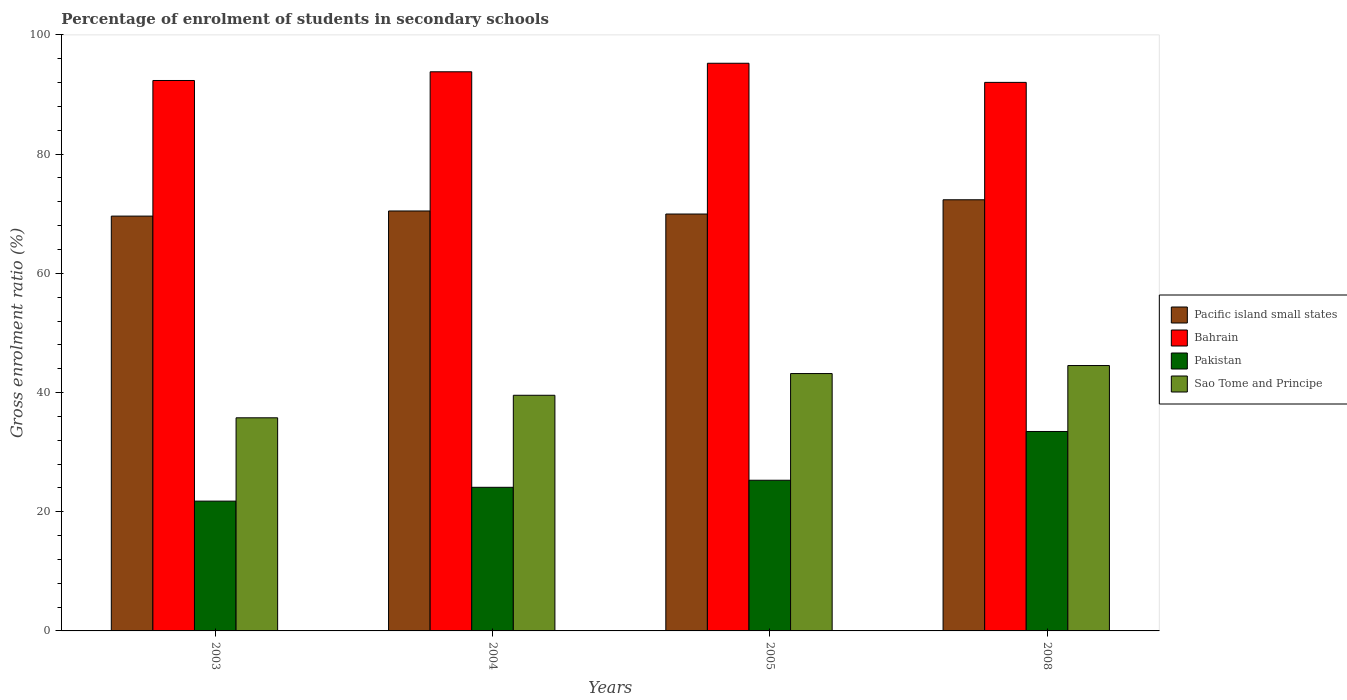How many groups of bars are there?
Your answer should be very brief. 4. Are the number of bars on each tick of the X-axis equal?
Your answer should be compact. Yes. In how many cases, is the number of bars for a given year not equal to the number of legend labels?
Your answer should be very brief. 0. What is the percentage of students enrolled in secondary schools in Sao Tome and Principe in 2005?
Provide a succinct answer. 43.18. Across all years, what is the maximum percentage of students enrolled in secondary schools in Pakistan?
Provide a short and direct response. 33.46. Across all years, what is the minimum percentage of students enrolled in secondary schools in Pacific island small states?
Your response must be concise. 69.6. What is the total percentage of students enrolled in secondary schools in Pakistan in the graph?
Give a very brief answer. 104.62. What is the difference between the percentage of students enrolled in secondary schools in Bahrain in 2003 and that in 2008?
Keep it short and to the point. 0.32. What is the difference between the percentage of students enrolled in secondary schools in Pakistan in 2008 and the percentage of students enrolled in secondary schools in Pacific island small states in 2003?
Provide a short and direct response. -36.14. What is the average percentage of students enrolled in secondary schools in Bahrain per year?
Your response must be concise. 93.36. In the year 2003, what is the difference between the percentage of students enrolled in secondary schools in Pacific island small states and percentage of students enrolled in secondary schools in Pakistan?
Your answer should be very brief. 47.82. What is the ratio of the percentage of students enrolled in secondary schools in Pacific island small states in 2004 to that in 2008?
Your answer should be compact. 0.97. Is the percentage of students enrolled in secondary schools in Sao Tome and Principe in 2003 less than that in 2005?
Give a very brief answer. Yes. What is the difference between the highest and the second highest percentage of students enrolled in secondary schools in Pakistan?
Your answer should be very brief. 8.18. What is the difference between the highest and the lowest percentage of students enrolled in secondary schools in Sao Tome and Principe?
Offer a terse response. 8.77. In how many years, is the percentage of students enrolled in secondary schools in Pakistan greater than the average percentage of students enrolled in secondary schools in Pakistan taken over all years?
Provide a succinct answer. 1. What does the 2nd bar from the left in 2003 represents?
Your answer should be very brief. Bahrain. Are all the bars in the graph horizontal?
Give a very brief answer. No. What is the difference between two consecutive major ticks on the Y-axis?
Provide a succinct answer. 20. Are the values on the major ticks of Y-axis written in scientific E-notation?
Keep it short and to the point. No. Does the graph contain grids?
Ensure brevity in your answer.  No. How many legend labels are there?
Offer a terse response. 4. How are the legend labels stacked?
Your answer should be compact. Vertical. What is the title of the graph?
Provide a short and direct response. Percentage of enrolment of students in secondary schools. Does "Bermuda" appear as one of the legend labels in the graph?
Make the answer very short. No. What is the Gross enrolment ratio (%) in Pacific island small states in 2003?
Make the answer very short. 69.6. What is the Gross enrolment ratio (%) in Bahrain in 2003?
Offer a very short reply. 92.35. What is the Gross enrolment ratio (%) of Pakistan in 2003?
Offer a terse response. 21.78. What is the Gross enrolment ratio (%) of Sao Tome and Principe in 2003?
Offer a very short reply. 35.76. What is the Gross enrolment ratio (%) in Pacific island small states in 2004?
Provide a short and direct response. 70.46. What is the Gross enrolment ratio (%) of Bahrain in 2004?
Your response must be concise. 93.81. What is the Gross enrolment ratio (%) of Pakistan in 2004?
Provide a short and direct response. 24.1. What is the Gross enrolment ratio (%) of Sao Tome and Principe in 2004?
Your answer should be compact. 39.54. What is the Gross enrolment ratio (%) of Pacific island small states in 2005?
Offer a terse response. 69.95. What is the Gross enrolment ratio (%) in Bahrain in 2005?
Make the answer very short. 95.25. What is the Gross enrolment ratio (%) of Pakistan in 2005?
Your response must be concise. 25.28. What is the Gross enrolment ratio (%) of Sao Tome and Principe in 2005?
Make the answer very short. 43.18. What is the Gross enrolment ratio (%) of Pacific island small states in 2008?
Your response must be concise. 72.34. What is the Gross enrolment ratio (%) in Bahrain in 2008?
Give a very brief answer. 92.04. What is the Gross enrolment ratio (%) in Pakistan in 2008?
Offer a very short reply. 33.46. What is the Gross enrolment ratio (%) of Sao Tome and Principe in 2008?
Give a very brief answer. 44.53. Across all years, what is the maximum Gross enrolment ratio (%) in Pacific island small states?
Give a very brief answer. 72.34. Across all years, what is the maximum Gross enrolment ratio (%) in Bahrain?
Your answer should be compact. 95.25. Across all years, what is the maximum Gross enrolment ratio (%) of Pakistan?
Your answer should be very brief. 33.46. Across all years, what is the maximum Gross enrolment ratio (%) in Sao Tome and Principe?
Your response must be concise. 44.53. Across all years, what is the minimum Gross enrolment ratio (%) in Pacific island small states?
Offer a terse response. 69.6. Across all years, what is the minimum Gross enrolment ratio (%) in Bahrain?
Your response must be concise. 92.04. Across all years, what is the minimum Gross enrolment ratio (%) of Pakistan?
Your answer should be compact. 21.78. Across all years, what is the minimum Gross enrolment ratio (%) in Sao Tome and Principe?
Make the answer very short. 35.76. What is the total Gross enrolment ratio (%) in Pacific island small states in the graph?
Provide a succinct answer. 282.35. What is the total Gross enrolment ratio (%) in Bahrain in the graph?
Offer a very short reply. 373.45. What is the total Gross enrolment ratio (%) of Pakistan in the graph?
Ensure brevity in your answer.  104.62. What is the total Gross enrolment ratio (%) in Sao Tome and Principe in the graph?
Ensure brevity in your answer.  163.01. What is the difference between the Gross enrolment ratio (%) of Pacific island small states in 2003 and that in 2004?
Your answer should be very brief. -0.86. What is the difference between the Gross enrolment ratio (%) in Bahrain in 2003 and that in 2004?
Make the answer very short. -1.46. What is the difference between the Gross enrolment ratio (%) in Pakistan in 2003 and that in 2004?
Provide a succinct answer. -2.32. What is the difference between the Gross enrolment ratio (%) in Sao Tome and Principe in 2003 and that in 2004?
Offer a terse response. -3.78. What is the difference between the Gross enrolment ratio (%) of Pacific island small states in 2003 and that in 2005?
Your answer should be compact. -0.35. What is the difference between the Gross enrolment ratio (%) in Bahrain in 2003 and that in 2005?
Make the answer very short. -2.89. What is the difference between the Gross enrolment ratio (%) in Pakistan in 2003 and that in 2005?
Your answer should be compact. -3.5. What is the difference between the Gross enrolment ratio (%) in Sao Tome and Principe in 2003 and that in 2005?
Offer a very short reply. -7.42. What is the difference between the Gross enrolment ratio (%) in Pacific island small states in 2003 and that in 2008?
Offer a very short reply. -2.74. What is the difference between the Gross enrolment ratio (%) in Bahrain in 2003 and that in 2008?
Give a very brief answer. 0.32. What is the difference between the Gross enrolment ratio (%) of Pakistan in 2003 and that in 2008?
Provide a short and direct response. -11.69. What is the difference between the Gross enrolment ratio (%) of Sao Tome and Principe in 2003 and that in 2008?
Your response must be concise. -8.77. What is the difference between the Gross enrolment ratio (%) in Pacific island small states in 2004 and that in 2005?
Offer a very short reply. 0.51. What is the difference between the Gross enrolment ratio (%) of Bahrain in 2004 and that in 2005?
Provide a succinct answer. -1.43. What is the difference between the Gross enrolment ratio (%) in Pakistan in 2004 and that in 2005?
Make the answer very short. -1.18. What is the difference between the Gross enrolment ratio (%) in Sao Tome and Principe in 2004 and that in 2005?
Give a very brief answer. -3.64. What is the difference between the Gross enrolment ratio (%) of Pacific island small states in 2004 and that in 2008?
Offer a very short reply. -1.88. What is the difference between the Gross enrolment ratio (%) of Bahrain in 2004 and that in 2008?
Make the answer very short. 1.78. What is the difference between the Gross enrolment ratio (%) of Pakistan in 2004 and that in 2008?
Keep it short and to the point. -9.37. What is the difference between the Gross enrolment ratio (%) of Sao Tome and Principe in 2004 and that in 2008?
Offer a very short reply. -4.99. What is the difference between the Gross enrolment ratio (%) of Pacific island small states in 2005 and that in 2008?
Offer a terse response. -2.39. What is the difference between the Gross enrolment ratio (%) of Bahrain in 2005 and that in 2008?
Your response must be concise. 3.21. What is the difference between the Gross enrolment ratio (%) of Pakistan in 2005 and that in 2008?
Provide a short and direct response. -8.18. What is the difference between the Gross enrolment ratio (%) in Sao Tome and Principe in 2005 and that in 2008?
Ensure brevity in your answer.  -1.34. What is the difference between the Gross enrolment ratio (%) of Pacific island small states in 2003 and the Gross enrolment ratio (%) of Bahrain in 2004?
Your response must be concise. -24.21. What is the difference between the Gross enrolment ratio (%) of Pacific island small states in 2003 and the Gross enrolment ratio (%) of Pakistan in 2004?
Provide a short and direct response. 45.5. What is the difference between the Gross enrolment ratio (%) of Pacific island small states in 2003 and the Gross enrolment ratio (%) of Sao Tome and Principe in 2004?
Your answer should be compact. 30.06. What is the difference between the Gross enrolment ratio (%) in Bahrain in 2003 and the Gross enrolment ratio (%) in Pakistan in 2004?
Provide a short and direct response. 68.26. What is the difference between the Gross enrolment ratio (%) of Bahrain in 2003 and the Gross enrolment ratio (%) of Sao Tome and Principe in 2004?
Make the answer very short. 52.82. What is the difference between the Gross enrolment ratio (%) in Pakistan in 2003 and the Gross enrolment ratio (%) in Sao Tome and Principe in 2004?
Give a very brief answer. -17.76. What is the difference between the Gross enrolment ratio (%) of Pacific island small states in 2003 and the Gross enrolment ratio (%) of Bahrain in 2005?
Keep it short and to the point. -25.65. What is the difference between the Gross enrolment ratio (%) in Pacific island small states in 2003 and the Gross enrolment ratio (%) in Pakistan in 2005?
Your answer should be very brief. 44.32. What is the difference between the Gross enrolment ratio (%) of Pacific island small states in 2003 and the Gross enrolment ratio (%) of Sao Tome and Principe in 2005?
Make the answer very short. 26.42. What is the difference between the Gross enrolment ratio (%) of Bahrain in 2003 and the Gross enrolment ratio (%) of Pakistan in 2005?
Provide a short and direct response. 67.07. What is the difference between the Gross enrolment ratio (%) of Bahrain in 2003 and the Gross enrolment ratio (%) of Sao Tome and Principe in 2005?
Keep it short and to the point. 49.17. What is the difference between the Gross enrolment ratio (%) of Pakistan in 2003 and the Gross enrolment ratio (%) of Sao Tome and Principe in 2005?
Your response must be concise. -21.4. What is the difference between the Gross enrolment ratio (%) of Pacific island small states in 2003 and the Gross enrolment ratio (%) of Bahrain in 2008?
Offer a very short reply. -22.44. What is the difference between the Gross enrolment ratio (%) of Pacific island small states in 2003 and the Gross enrolment ratio (%) of Pakistan in 2008?
Your answer should be very brief. 36.14. What is the difference between the Gross enrolment ratio (%) in Pacific island small states in 2003 and the Gross enrolment ratio (%) in Sao Tome and Principe in 2008?
Your answer should be compact. 25.07. What is the difference between the Gross enrolment ratio (%) in Bahrain in 2003 and the Gross enrolment ratio (%) in Pakistan in 2008?
Ensure brevity in your answer.  58.89. What is the difference between the Gross enrolment ratio (%) of Bahrain in 2003 and the Gross enrolment ratio (%) of Sao Tome and Principe in 2008?
Ensure brevity in your answer.  47.83. What is the difference between the Gross enrolment ratio (%) of Pakistan in 2003 and the Gross enrolment ratio (%) of Sao Tome and Principe in 2008?
Make the answer very short. -22.75. What is the difference between the Gross enrolment ratio (%) of Pacific island small states in 2004 and the Gross enrolment ratio (%) of Bahrain in 2005?
Offer a terse response. -24.79. What is the difference between the Gross enrolment ratio (%) of Pacific island small states in 2004 and the Gross enrolment ratio (%) of Pakistan in 2005?
Give a very brief answer. 45.18. What is the difference between the Gross enrolment ratio (%) in Pacific island small states in 2004 and the Gross enrolment ratio (%) in Sao Tome and Principe in 2005?
Give a very brief answer. 27.28. What is the difference between the Gross enrolment ratio (%) of Bahrain in 2004 and the Gross enrolment ratio (%) of Pakistan in 2005?
Make the answer very short. 68.53. What is the difference between the Gross enrolment ratio (%) of Bahrain in 2004 and the Gross enrolment ratio (%) of Sao Tome and Principe in 2005?
Give a very brief answer. 50.63. What is the difference between the Gross enrolment ratio (%) in Pakistan in 2004 and the Gross enrolment ratio (%) in Sao Tome and Principe in 2005?
Offer a very short reply. -19.08. What is the difference between the Gross enrolment ratio (%) of Pacific island small states in 2004 and the Gross enrolment ratio (%) of Bahrain in 2008?
Your response must be concise. -21.58. What is the difference between the Gross enrolment ratio (%) in Pacific island small states in 2004 and the Gross enrolment ratio (%) in Pakistan in 2008?
Keep it short and to the point. 37. What is the difference between the Gross enrolment ratio (%) of Pacific island small states in 2004 and the Gross enrolment ratio (%) of Sao Tome and Principe in 2008?
Provide a short and direct response. 25.93. What is the difference between the Gross enrolment ratio (%) in Bahrain in 2004 and the Gross enrolment ratio (%) in Pakistan in 2008?
Offer a terse response. 60.35. What is the difference between the Gross enrolment ratio (%) of Bahrain in 2004 and the Gross enrolment ratio (%) of Sao Tome and Principe in 2008?
Your answer should be compact. 49.29. What is the difference between the Gross enrolment ratio (%) of Pakistan in 2004 and the Gross enrolment ratio (%) of Sao Tome and Principe in 2008?
Offer a very short reply. -20.43. What is the difference between the Gross enrolment ratio (%) of Pacific island small states in 2005 and the Gross enrolment ratio (%) of Bahrain in 2008?
Keep it short and to the point. -22.09. What is the difference between the Gross enrolment ratio (%) of Pacific island small states in 2005 and the Gross enrolment ratio (%) of Pakistan in 2008?
Make the answer very short. 36.49. What is the difference between the Gross enrolment ratio (%) of Pacific island small states in 2005 and the Gross enrolment ratio (%) of Sao Tome and Principe in 2008?
Offer a very short reply. 25.42. What is the difference between the Gross enrolment ratio (%) of Bahrain in 2005 and the Gross enrolment ratio (%) of Pakistan in 2008?
Provide a short and direct response. 61.78. What is the difference between the Gross enrolment ratio (%) of Bahrain in 2005 and the Gross enrolment ratio (%) of Sao Tome and Principe in 2008?
Your answer should be very brief. 50.72. What is the difference between the Gross enrolment ratio (%) in Pakistan in 2005 and the Gross enrolment ratio (%) in Sao Tome and Principe in 2008?
Make the answer very short. -19.25. What is the average Gross enrolment ratio (%) in Pacific island small states per year?
Keep it short and to the point. 70.59. What is the average Gross enrolment ratio (%) of Bahrain per year?
Ensure brevity in your answer.  93.36. What is the average Gross enrolment ratio (%) in Pakistan per year?
Provide a succinct answer. 26.16. What is the average Gross enrolment ratio (%) of Sao Tome and Principe per year?
Offer a terse response. 40.75. In the year 2003, what is the difference between the Gross enrolment ratio (%) of Pacific island small states and Gross enrolment ratio (%) of Bahrain?
Offer a terse response. -22.75. In the year 2003, what is the difference between the Gross enrolment ratio (%) of Pacific island small states and Gross enrolment ratio (%) of Pakistan?
Offer a terse response. 47.82. In the year 2003, what is the difference between the Gross enrolment ratio (%) of Pacific island small states and Gross enrolment ratio (%) of Sao Tome and Principe?
Provide a short and direct response. 33.84. In the year 2003, what is the difference between the Gross enrolment ratio (%) in Bahrain and Gross enrolment ratio (%) in Pakistan?
Make the answer very short. 70.58. In the year 2003, what is the difference between the Gross enrolment ratio (%) in Bahrain and Gross enrolment ratio (%) in Sao Tome and Principe?
Ensure brevity in your answer.  56.6. In the year 2003, what is the difference between the Gross enrolment ratio (%) in Pakistan and Gross enrolment ratio (%) in Sao Tome and Principe?
Ensure brevity in your answer.  -13.98. In the year 2004, what is the difference between the Gross enrolment ratio (%) in Pacific island small states and Gross enrolment ratio (%) in Bahrain?
Your response must be concise. -23.35. In the year 2004, what is the difference between the Gross enrolment ratio (%) of Pacific island small states and Gross enrolment ratio (%) of Pakistan?
Provide a short and direct response. 46.36. In the year 2004, what is the difference between the Gross enrolment ratio (%) in Pacific island small states and Gross enrolment ratio (%) in Sao Tome and Principe?
Provide a short and direct response. 30.92. In the year 2004, what is the difference between the Gross enrolment ratio (%) of Bahrain and Gross enrolment ratio (%) of Pakistan?
Make the answer very short. 69.72. In the year 2004, what is the difference between the Gross enrolment ratio (%) of Bahrain and Gross enrolment ratio (%) of Sao Tome and Principe?
Provide a short and direct response. 54.28. In the year 2004, what is the difference between the Gross enrolment ratio (%) in Pakistan and Gross enrolment ratio (%) in Sao Tome and Principe?
Provide a short and direct response. -15.44. In the year 2005, what is the difference between the Gross enrolment ratio (%) in Pacific island small states and Gross enrolment ratio (%) in Bahrain?
Make the answer very short. -25.3. In the year 2005, what is the difference between the Gross enrolment ratio (%) in Pacific island small states and Gross enrolment ratio (%) in Pakistan?
Give a very brief answer. 44.67. In the year 2005, what is the difference between the Gross enrolment ratio (%) of Pacific island small states and Gross enrolment ratio (%) of Sao Tome and Principe?
Provide a short and direct response. 26.77. In the year 2005, what is the difference between the Gross enrolment ratio (%) in Bahrain and Gross enrolment ratio (%) in Pakistan?
Offer a terse response. 69.97. In the year 2005, what is the difference between the Gross enrolment ratio (%) in Bahrain and Gross enrolment ratio (%) in Sao Tome and Principe?
Provide a succinct answer. 52.06. In the year 2005, what is the difference between the Gross enrolment ratio (%) in Pakistan and Gross enrolment ratio (%) in Sao Tome and Principe?
Offer a terse response. -17.9. In the year 2008, what is the difference between the Gross enrolment ratio (%) of Pacific island small states and Gross enrolment ratio (%) of Bahrain?
Give a very brief answer. -19.7. In the year 2008, what is the difference between the Gross enrolment ratio (%) in Pacific island small states and Gross enrolment ratio (%) in Pakistan?
Keep it short and to the point. 38.88. In the year 2008, what is the difference between the Gross enrolment ratio (%) of Pacific island small states and Gross enrolment ratio (%) of Sao Tome and Principe?
Make the answer very short. 27.81. In the year 2008, what is the difference between the Gross enrolment ratio (%) in Bahrain and Gross enrolment ratio (%) in Pakistan?
Provide a short and direct response. 58.57. In the year 2008, what is the difference between the Gross enrolment ratio (%) of Bahrain and Gross enrolment ratio (%) of Sao Tome and Principe?
Offer a terse response. 47.51. In the year 2008, what is the difference between the Gross enrolment ratio (%) of Pakistan and Gross enrolment ratio (%) of Sao Tome and Principe?
Make the answer very short. -11.06. What is the ratio of the Gross enrolment ratio (%) in Pacific island small states in 2003 to that in 2004?
Make the answer very short. 0.99. What is the ratio of the Gross enrolment ratio (%) in Bahrain in 2003 to that in 2004?
Offer a very short reply. 0.98. What is the ratio of the Gross enrolment ratio (%) in Pakistan in 2003 to that in 2004?
Give a very brief answer. 0.9. What is the ratio of the Gross enrolment ratio (%) in Sao Tome and Principe in 2003 to that in 2004?
Provide a succinct answer. 0.9. What is the ratio of the Gross enrolment ratio (%) of Bahrain in 2003 to that in 2005?
Provide a short and direct response. 0.97. What is the ratio of the Gross enrolment ratio (%) in Pakistan in 2003 to that in 2005?
Make the answer very short. 0.86. What is the ratio of the Gross enrolment ratio (%) in Sao Tome and Principe in 2003 to that in 2005?
Provide a succinct answer. 0.83. What is the ratio of the Gross enrolment ratio (%) in Pacific island small states in 2003 to that in 2008?
Your answer should be compact. 0.96. What is the ratio of the Gross enrolment ratio (%) of Pakistan in 2003 to that in 2008?
Offer a very short reply. 0.65. What is the ratio of the Gross enrolment ratio (%) of Sao Tome and Principe in 2003 to that in 2008?
Ensure brevity in your answer.  0.8. What is the ratio of the Gross enrolment ratio (%) of Pacific island small states in 2004 to that in 2005?
Offer a terse response. 1.01. What is the ratio of the Gross enrolment ratio (%) in Pakistan in 2004 to that in 2005?
Provide a short and direct response. 0.95. What is the ratio of the Gross enrolment ratio (%) in Sao Tome and Principe in 2004 to that in 2005?
Your response must be concise. 0.92. What is the ratio of the Gross enrolment ratio (%) of Pacific island small states in 2004 to that in 2008?
Keep it short and to the point. 0.97. What is the ratio of the Gross enrolment ratio (%) of Bahrain in 2004 to that in 2008?
Give a very brief answer. 1.02. What is the ratio of the Gross enrolment ratio (%) of Pakistan in 2004 to that in 2008?
Provide a short and direct response. 0.72. What is the ratio of the Gross enrolment ratio (%) of Sao Tome and Principe in 2004 to that in 2008?
Your answer should be very brief. 0.89. What is the ratio of the Gross enrolment ratio (%) of Pacific island small states in 2005 to that in 2008?
Make the answer very short. 0.97. What is the ratio of the Gross enrolment ratio (%) in Bahrain in 2005 to that in 2008?
Your answer should be compact. 1.03. What is the ratio of the Gross enrolment ratio (%) in Pakistan in 2005 to that in 2008?
Your response must be concise. 0.76. What is the ratio of the Gross enrolment ratio (%) in Sao Tome and Principe in 2005 to that in 2008?
Your response must be concise. 0.97. What is the difference between the highest and the second highest Gross enrolment ratio (%) in Pacific island small states?
Your answer should be compact. 1.88. What is the difference between the highest and the second highest Gross enrolment ratio (%) in Bahrain?
Give a very brief answer. 1.43. What is the difference between the highest and the second highest Gross enrolment ratio (%) of Pakistan?
Make the answer very short. 8.18. What is the difference between the highest and the second highest Gross enrolment ratio (%) of Sao Tome and Principe?
Your answer should be compact. 1.34. What is the difference between the highest and the lowest Gross enrolment ratio (%) of Pacific island small states?
Make the answer very short. 2.74. What is the difference between the highest and the lowest Gross enrolment ratio (%) of Bahrain?
Offer a very short reply. 3.21. What is the difference between the highest and the lowest Gross enrolment ratio (%) of Pakistan?
Offer a very short reply. 11.69. What is the difference between the highest and the lowest Gross enrolment ratio (%) of Sao Tome and Principe?
Your answer should be very brief. 8.77. 